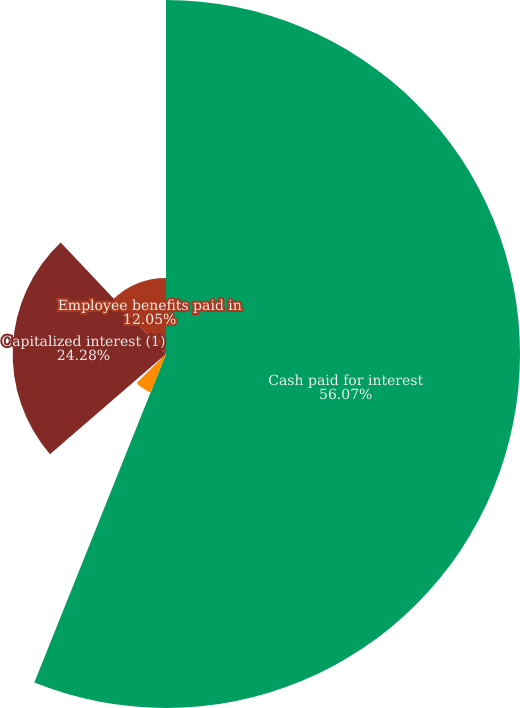Convert chart to OTSL. <chart><loc_0><loc_0><loc_500><loc_500><pie_chart><fcel>Cash paid for interest<fcel>Cash received for interest<fcel>Cash paid for income taxes<fcel>Capitalized interest (1)<fcel>Employee benefits paid in<nl><fcel>56.06%<fcel>6.55%<fcel>1.05%<fcel>24.28%<fcel>12.05%<nl></chart> 